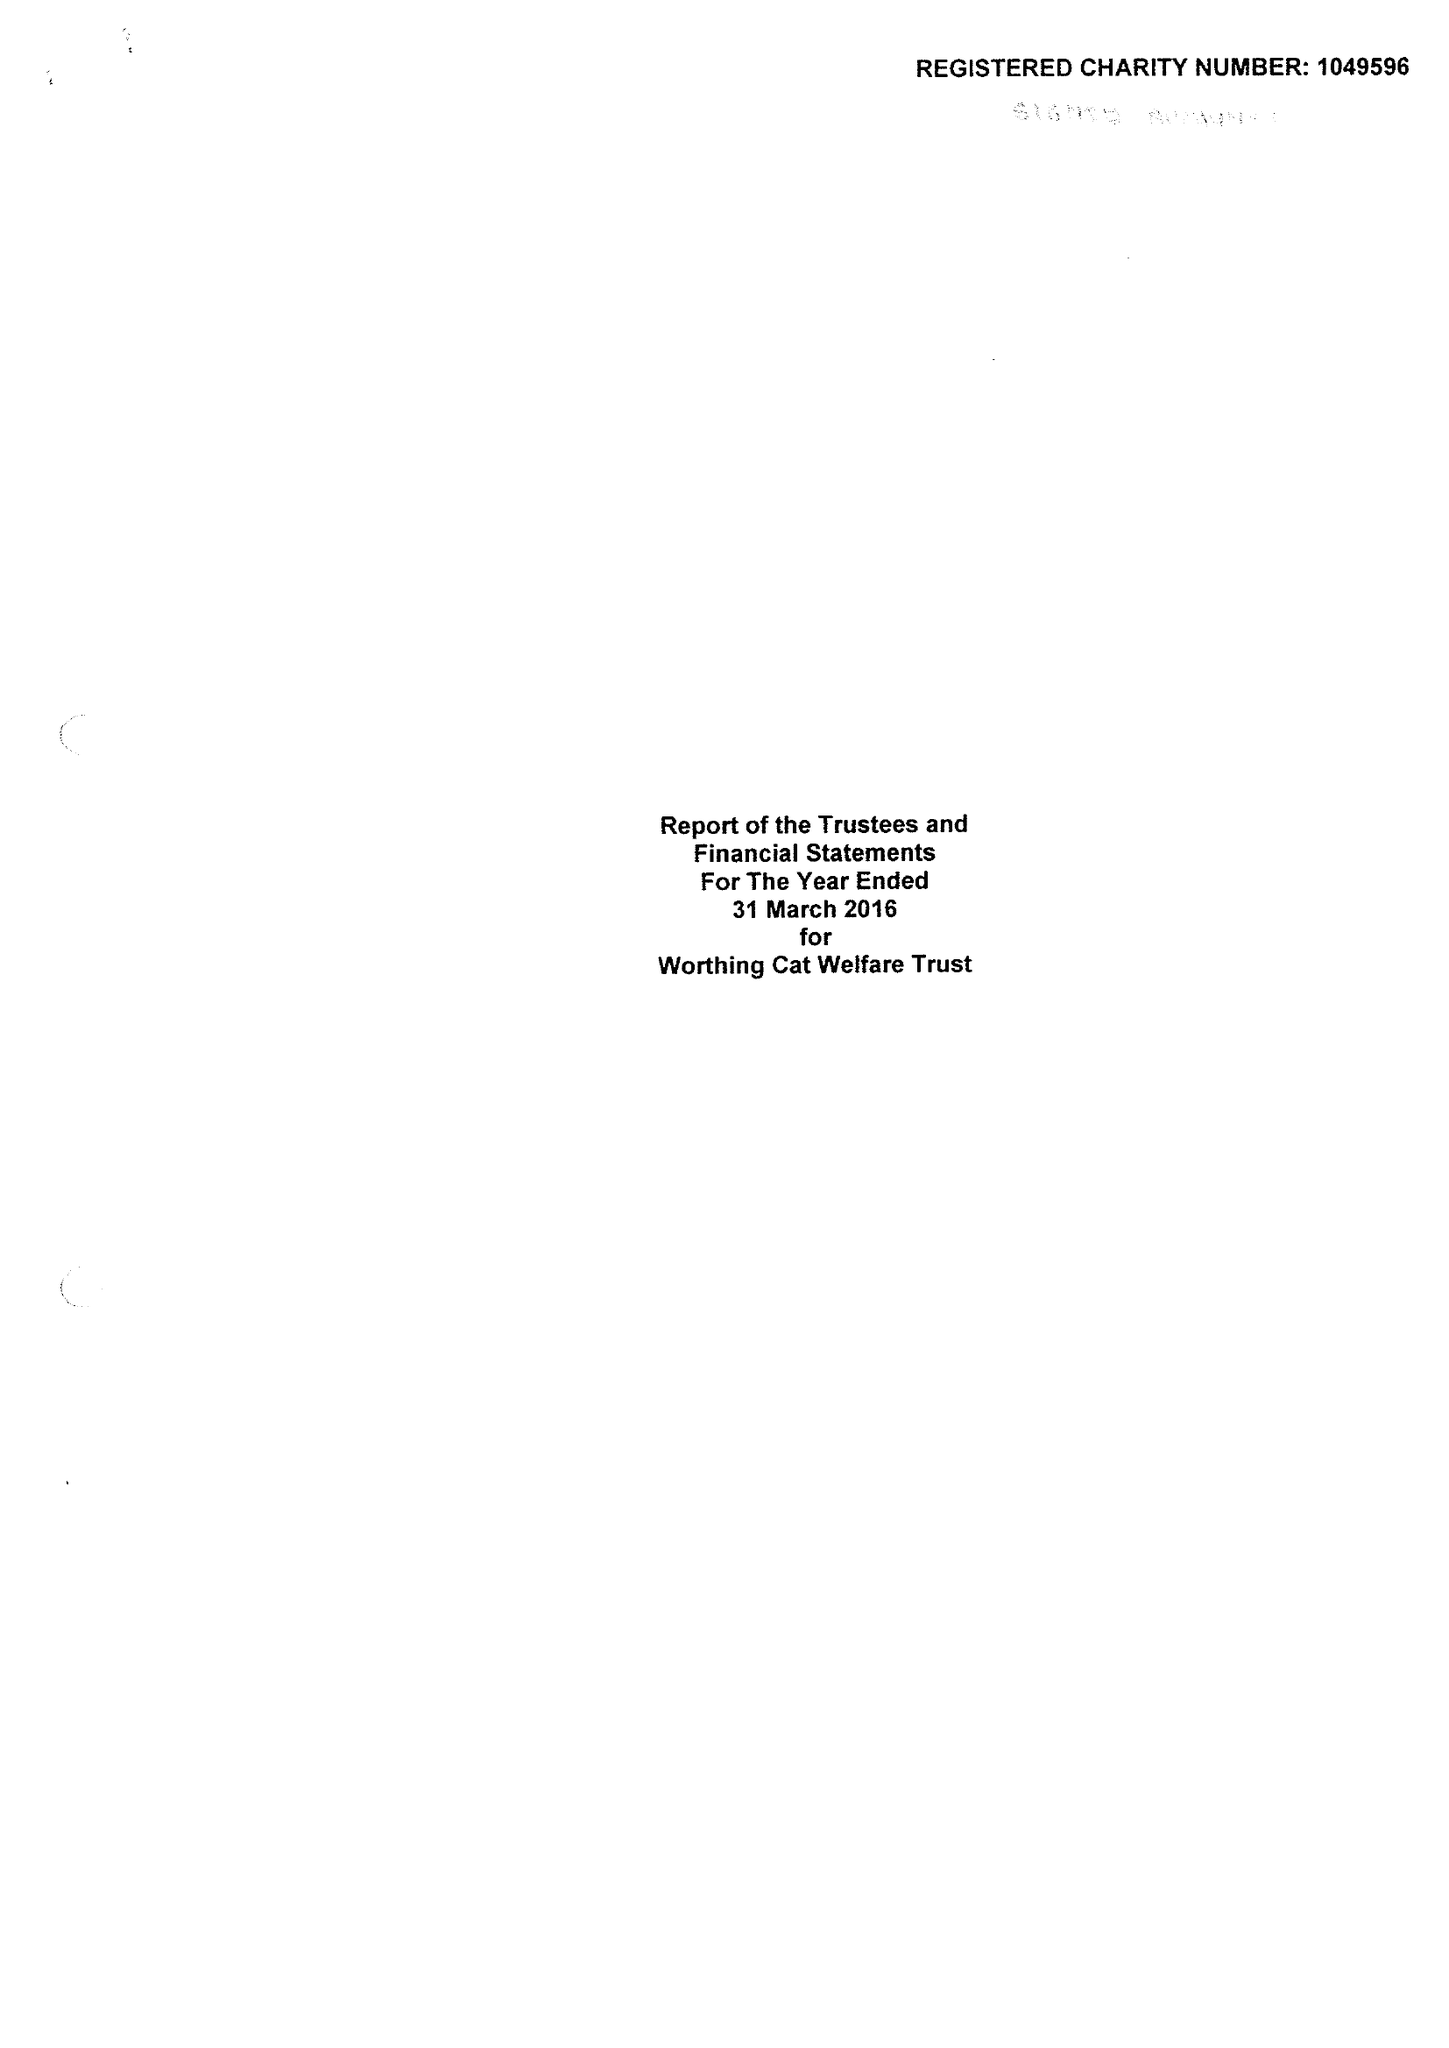What is the value for the address__street_line?
Answer the question using a single word or phrase. 141 DOWNSIDE AVENUE 